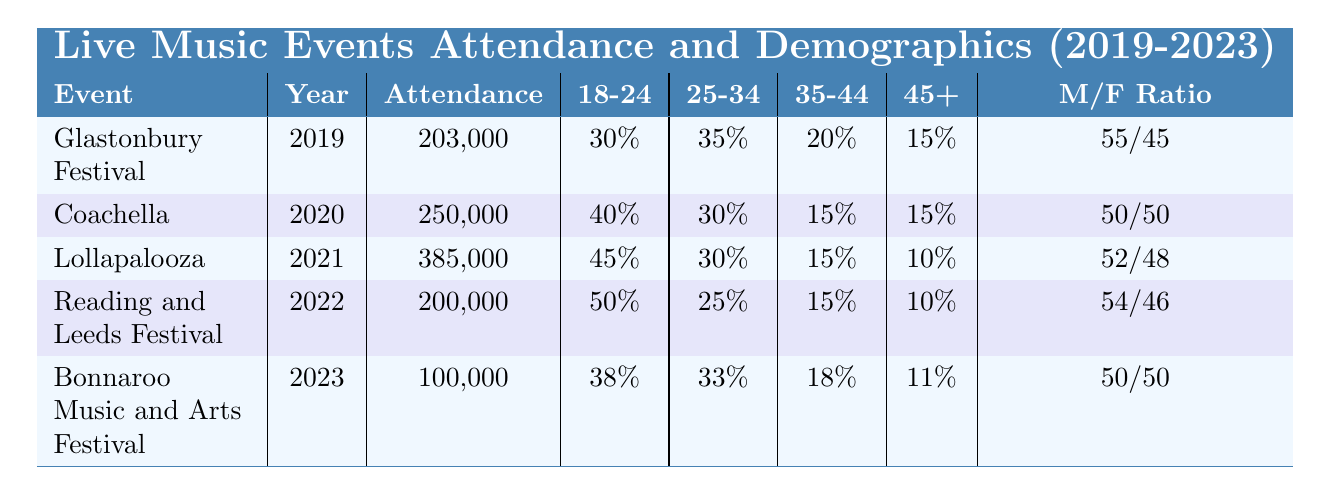What was the attendance at Lollapalooza in 2021? The table shows that Lollapalooza occurred in 2021 with an attendance figure of 385,000.
Answer: 385,000 Which event had the highest attendance from 2019 to 2023? By comparing the attendance figures in the table, Lollapalooza in 2021 has the highest attendance of 385,000.
Answer: Lollapalooza What percentage of attendees at the Reading and Leeds Festival in 2022 were aged 18-24? The table shows that 50% of attendees at the Reading and Leeds Festival in 2022 were aged 18-24.
Answer: 50% Was there a decrease in attendance from 2021 to 2023? In 2021, attendance was 385,000, and in 2023, it was 100,000. This shows a significant decrease.
Answer: Yes What is the gender ratio of attendees at Coachella in 2020? According to the table, the gender ratio at Coachella in 2020 was 50% male and 50% female.
Answer: 50/50 What was the average percentage of attendees aged 25-34 across all events from 2019 to 2023? The percentages for 25-34 year-olds are: 35% (Glastonbury), 30% (Coachella), 30% (Lollapalooza), 25% (Reading and Leeds), and 33% (Bonnaroo). Summing these gives 153%, and dividing by 5 gives an average of 30.6%.
Answer: 30.6% Did more attendees aged 45+ attend Glastonbury than Bonnaroo? Glastonbury had 15% of attendees aged 45+, while Bonnaroo had 11%. Therefore, more attendees aged 45+ attended Glastonbury.
Answer: Yes How many fewer attendees were at Bonnaroo compared to Lollapalooza? The attendance at Bonnaroo was 100,000, while Lollapalooza's attendance was 385,000. The difference is 385,000 - 100,000 = 285,000, indicating that Bonnaroo had 285,000 fewer attendees.
Answer: 285,000 What percentage of attendees at the 2023 Bonnaroo festival were aged 35-44? The table shows that 18% of attendees at Bonnaroo in 2023 were aged 35-44.
Answer: 18% 